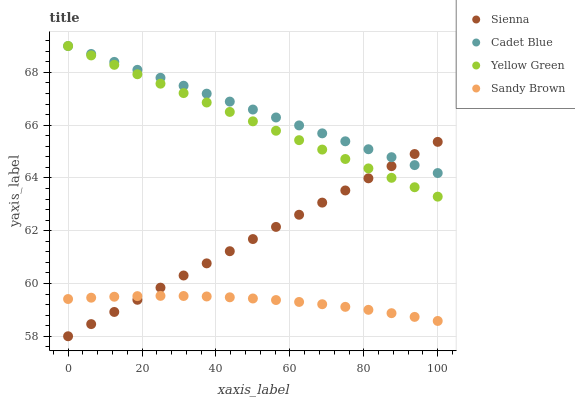Does Sandy Brown have the minimum area under the curve?
Answer yes or no. Yes. Does Cadet Blue have the maximum area under the curve?
Answer yes or no. Yes. Does Cadet Blue have the minimum area under the curve?
Answer yes or no. No. Does Sandy Brown have the maximum area under the curve?
Answer yes or no. No. Is Sienna the smoothest?
Answer yes or no. Yes. Is Sandy Brown the roughest?
Answer yes or no. Yes. Is Cadet Blue the smoothest?
Answer yes or no. No. Is Cadet Blue the roughest?
Answer yes or no. No. Does Sienna have the lowest value?
Answer yes or no. Yes. Does Sandy Brown have the lowest value?
Answer yes or no. No. Does Yellow Green have the highest value?
Answer yes or no. Yes. Does Sandy Brown have the highest value?
Answer yes or no. No. Is Sandy Brown less than Cadet Blue?
Answer yes or no. Yes. Is Cadet Blue greater than Sandy Brown?
Answer yes or no. Yes. Does Cadet Blue intersect Yellow Green?
Answer yes or no. Yes. Is Cadet Blue less than Yellow Green?
Answer yes or no. No. Is Cadet Blue greater than Yellow Green?
Answer yes or no. No. Does Sandy Brown intersect Cadet Blue?
Answer yes or no. No. 